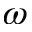<formula> <loc_0><loc_0><loc_500><loc_500>\omega</formula> 